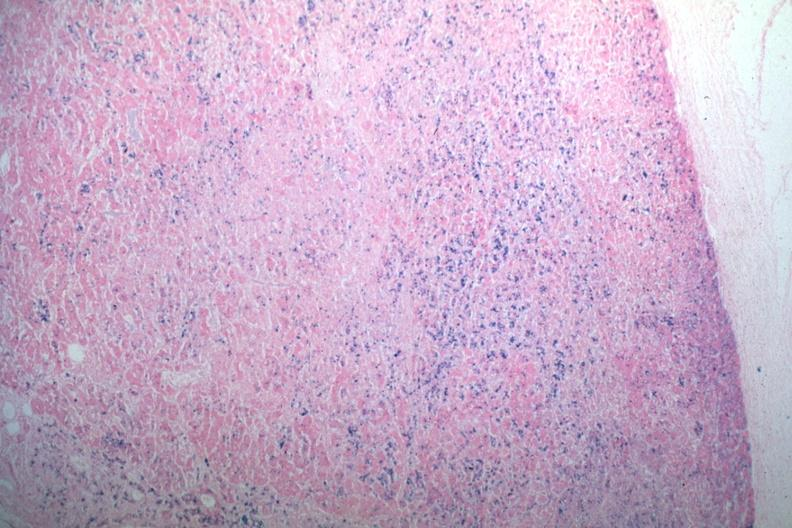s lateral view present?
Answer the question using a single word or phrase. No 